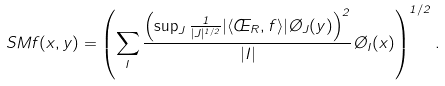<formula> <loc_0><loc_0><loc_500><loc_500>S M f ( x , y ) = \left ( \sum _ { I } \frac { \left ( \sup _ { J } \frac { 1 } { | J | ^ { 1 / 2 } } | \langle \phi _ { R } , f \rangle | \chi _ { J } ( y ) \right ) ^ { 2 } } { | I | } \chi _ { I } ( x ) \right ) ^ { 1 / 2 } .</formula> 